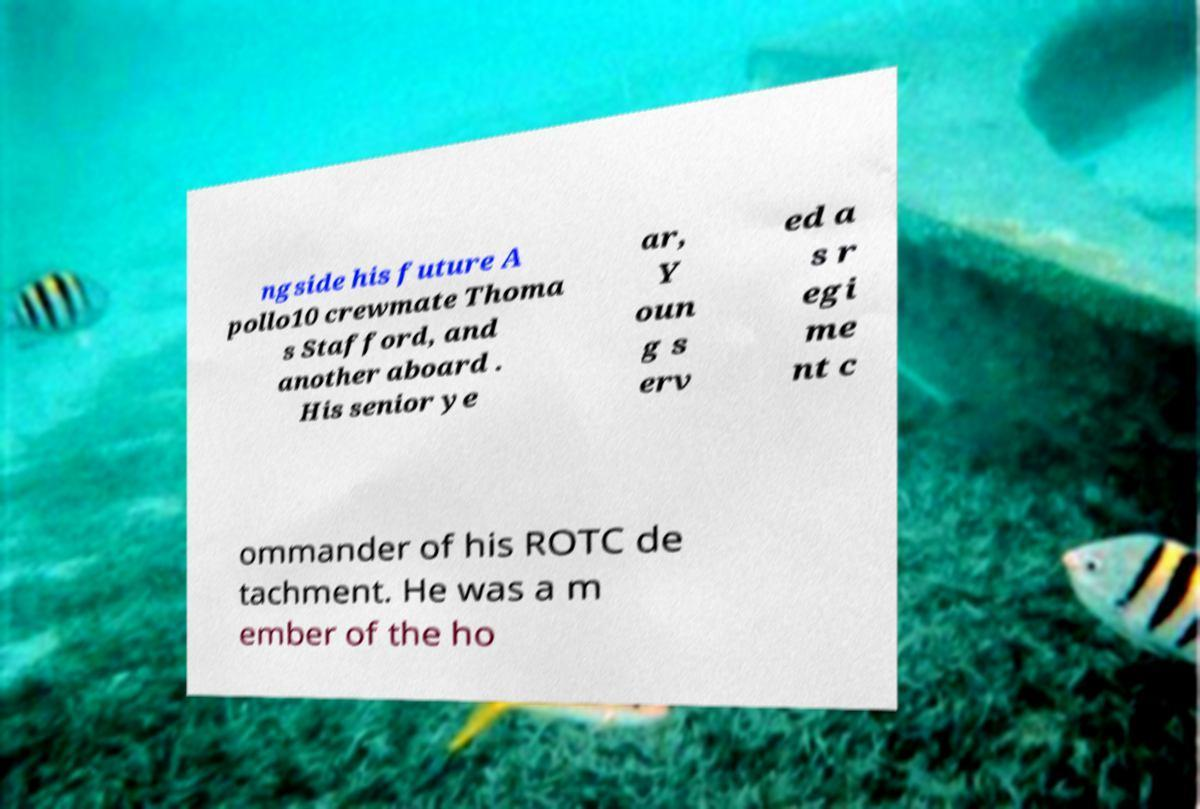What messages or text are displayed in this image? I need them in a readable, typed format. ngside his future A pollo10 crewmate Thoma s Stafford, and another aboard . His senior ye ar, Y oun g s erv ed a s r egi me nt c ommander of his ROTC de tachment. He was a m ember of the ho 